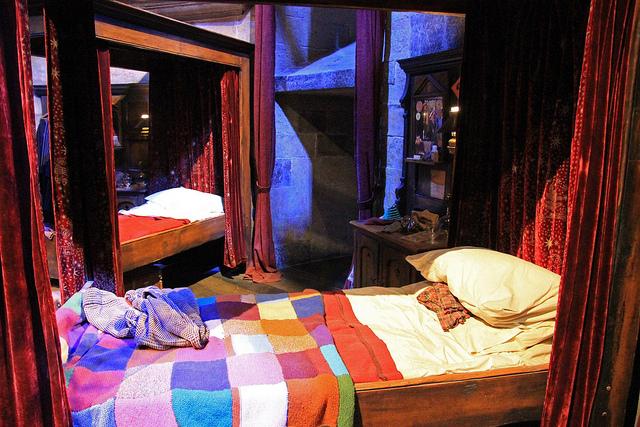Is anyone sleeping in this bed?
Keep it brief. No. What color is the pillow?
Be succinct. White. Which side of the picture is the pillow on?
Quick response, please. Right. 